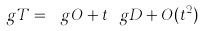Convert formula to latex. <formula><loc_0><loc_0><loc_500><loc_500>\ g T = \ g O + t \ g D + O ( t ^ { 2 } )</formula> 